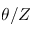<formula> <loc_0><loc_0><loc_500><loc_500>\theta / Z</formula> 